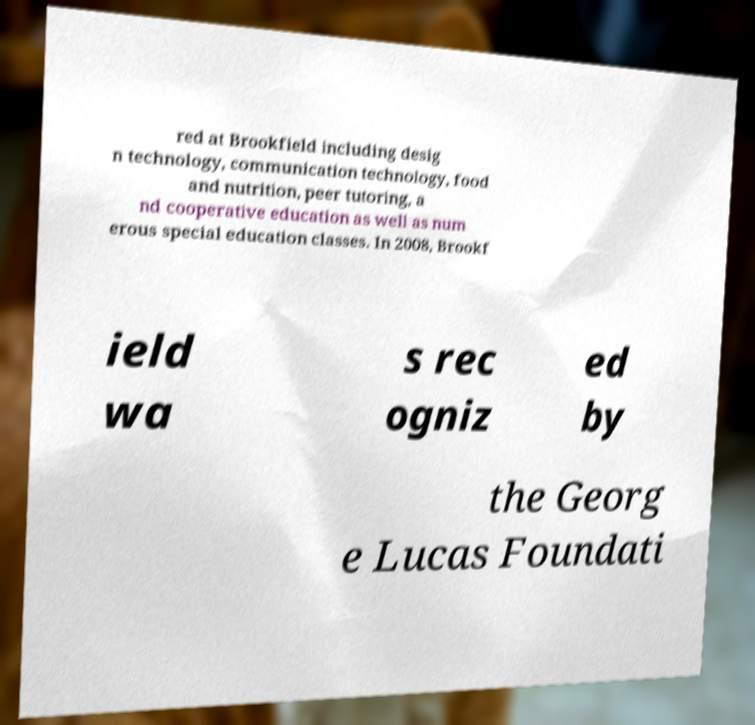Could you extract and type out the text from this image? red at Brookfield including desig n technology, communication technology, food and nutrition, peer tutoring, a nd cooperative education as well as num erous special education classes. In 2008, Brookf ield wa s rec ogniz ed by the Georg e Lucas Foundati 